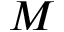<formula> <loc_0><loc_0><loc_500><loc_500>M</formula> 